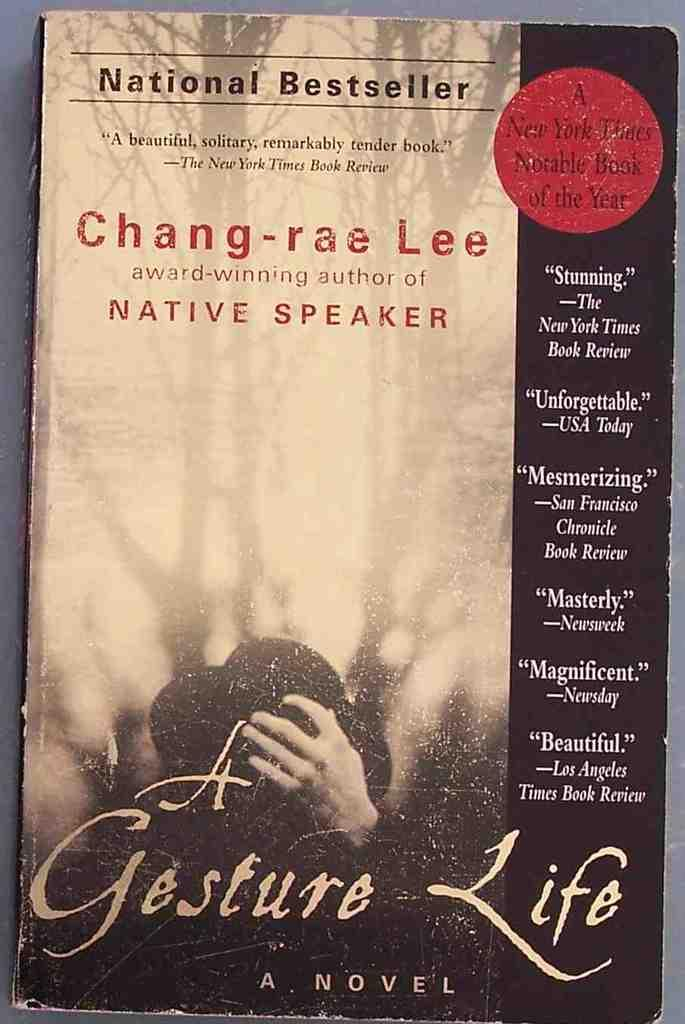<image>
Relay a brief, clear account of the picture shown. A National Bestseller book by Chang-rae Lee called A Gesture Life 